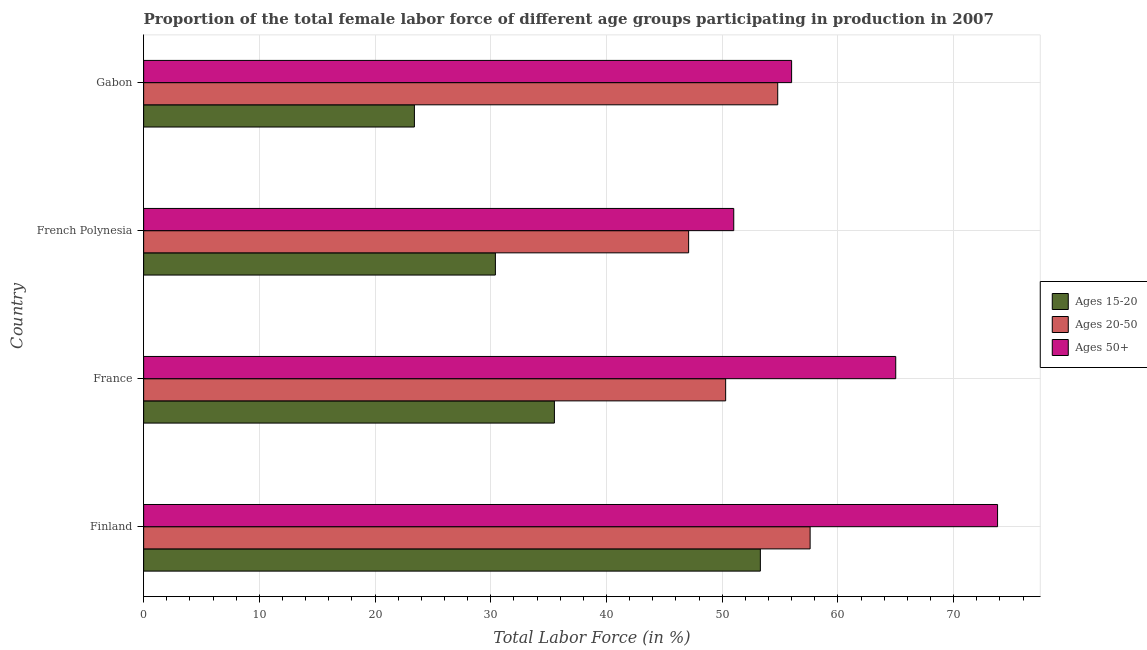How many different coloured bars are there?
Your answer should be compact. 3. Are the number of bars per tick equal to the number of legend labels?
Keep it short and to the point. Yes. How many bars are there on the 4th tick from the top?
Provide a succinct answer. 3. How many bars are there on the 4th tick from the bottom?
Offer a very short reply. 3. What is the label of the 3rd group of bars from the top?
Ensure brevity in your answer.  France. What is the percentage of female labor force within the age group 15-20 in French Polynesia?
Your answer should be very brief. 30.4. Across all countries, what is the maximum percentage of female labor force above age 50?
Your answer should be compact. 73.8. In which country was the percentage of female labor force within the age group 15-20 minimum?
Provide a succinct answer. Gabon. What is the total percentage of female labor force within the age group 15-20 in the graph?
Your answer should be very brief. 142.6. What is the difference between the percentage of female labor force within the age group 20-50 in French Polynesia and the percentage of female labor force above age 50 in France?
Offer a terse response. -17.9. What is the average percentage of female labor force within the age group 15-20 per country?
Provide a succinct answer. 35.65. What is the difference between the percentage of female labor force within the age group 20-50 and percentage of female labor force above age 50 in French Polynesia?
Your answer should be very brief. -3.9. In how many countries, is the percentage of female labor force above age 50 greater than 24 %?
Make the answer very short. 4. What is the ratio of the percentage of female labor force above age 50 in Finland to that in French Polynesia?
Give a very brief answer. 1.45. Is the percentage of female labor force within the age group 15-20 in Finland less than that in Gabon?
Provide a short and direct response. No. What is the difference between the highest and the lowest percentage of female labor force within the age group 15-20?
Provide a short and direct response. 29.9. In how many countries, is the percentage of female labor force above age 50 greater than the average percentage of female labor force above age 50 taken over all countries?
Ensure brevity in your answer.  2. Is the sum of the percentage of female labor force within the age group 15-20 in Finland and French Polynesia greater than the maximum percentage of female labor force within the age group 20-50 across all countries?
Give a very brief answer. Yes. What does the 1st bar from the top in Finland represents?
Offer a very short reply. Ages 50+. What does the 1st bar from the bottom in France represents?
Your answer should be very brief. Ages 15-20. What is the difference between two consecutive major ticks on the X-axis?
Make the answer very short. 10. Are the values on the major ticks of X-axis written in scientific E-notation?
Provide a short and direct response. No. Does the graph contain grids?
Give a very brief answer. Yes. How many legend labels are there?
Give a very brief answer. 3. What is the title of the graph?
Make the answer very short. Proportion of the total female labor force of different age groups participating in production in 2007. What is the Total Labor Force (in %) in Ages 15-20 in Finland?
Provide a short and direct response. 53.3. What is the Total Labor Force (in %) of Ages 20-50 in Finland?
Ensure brevity in your answer.  57.6. What is the Total Labor Force (in %) in Ages 50+ in Finland?
Give a very brief answer. 73.8. What is the Total Labor Force (in %) of Ages 15-20 in France?
Make the answer very short. 35.5. What is the Total Labor Force (in %) in Ages 20-50 in France?
Keep it short and to the point. 50.3. What is the Total Labor Force (in %) of Ages 15-20 in French Polynesia?
Your response must be concise. 30.4. What is the Total Labor Force (in %) in Ages 20-50 in French Polynesia?
Keep it short and to the point. 47.1. What is the Total Labor Force (in %) in Ages 15-20 in Gabon?
Offer a very short reply. 23.4. What is the Total Labor Force (in %) in Ages 20-50 in Gabon?
Your response must be concise. 54.8. Across all countries, what is the maximum Total Labor Force (in %) of Ages 15-20?
Provide a succinct answer. 53.3. Across all countries, what is the maximum Total Labor Force (in %) in Ages 20-50?
Offer a terse response. 57.6. Across all countries, what is the maximum Total Labor Force (in %) of Ages 50+?
Make the answer very short. 73.8. Across all countries, what is the minimum Total Labor Force (in %) of Ages 15-20?
Your response must be concise. 23.4. Across all countries, what is the minimum Total Labor Force (in %) of Ages 20-50?
Offer a very short reply. 47.1. Across all countries, what is the minimum Total Labor Force (in %) in Ages 50+?
Offer a very short reply. 51. What is the total Total Labor Force (in %) of Ages 15-20 in the graph?
Keep it short and to the point. 142.6. What is the total Total Labor Force (in %) of Ages 20-50 in the graph?
Give a very brief answer. 209.8. What is the total Total Labor Force (in %) of Ages 50+ in the graph?
Your answer should be very brief. 245.8. What is the difference between the Total Labor Force (in %) of Ages 15-20 in Finland and that in France?
Your response must be concise. 17.8. What is the difference between the Total Labor Force (in %) in Ages 20-50 in Finland and that in France?
Make the answer very short. 7.3. What is the difference between the Total Labor Force (in %) of Ages 50+ in Finland and that in France?
Give a very brief answer. 8.8. What is the difference between the Total Labor Force (in %) in Ages 15-20 in Finland and that in French Polynesia?
Your answer should be compact. 22.9. What is the difference between the Total Labor Force (in %) of Ages 20-50 in Finland and that in French Polynesia?
Provide a succinct answer. 10.5. What is the difference between the Total Labor Force (in %) in Ages 50+ in Finland and that in French Polynesia?
Provide a short and direct response. 22.8. What is the difference between the Total Labor Force (in %) of Ages 15-20 in Finland and that in Gabon?
Make the answer very short. 29.9. What is the difference between the Total Labor Force (in %) of Ages 50+ in Finland and that in Gabon?
Your response must be concise. 17.8. What is the difference between the Total Labor Force (in %) of Ages 20-50 in France and that in Gabon?
Offer a terse response. -4.5. What is the difference between the Total Labor Force (in %) of Ages 15-20 in French Polynesia and that in Gabon?
Your response must be concise. 7. What is the difference between the Total Labor Force (in %) of Ages 20-50 in French Polynesia and that in Gabon?
Provide a succinct answer. -7.7. What is the difference between the Total Labor Force (in %) in Ages 50+ in French Polynesia and that in Gabon?
Your answer should be compact. -5. What is the difference between the Total Labor Force (in %) in Ages 15-20 in Finland and the Total Labor Force (in %) in Ages 20-50 in France?
Make the answer very short. 3. What is the difference between the Total Labor Force (in %) of Ages 15-20 in Finland and the Total Labor Force (in %) of Ages 50+ in France?
Your answer should be compact. -11.7. What is the difference between the Total Labor Force (in %) of Ages 15-20 in Finland and the Total Labor Force (in %) of Ages 50+ in French Polynesia?
Keep it short and to the point. 2.3. What is the difference between the Total Labor Force (in %) in Ages 20-50 in Finland and the Total Labor Force (in %) in Ages 50+ in French Polynesia?
Your answer should be very brief. 6.6. What is the difference between the Total Labor Force (in %) in Ages 15-20 in Finland and the Total Labor Force (in %) in Ages 20-50 in Gabon?
Provide a succinct answer. -1.5. What is the difference between the Total Labor Force (in %) of Ages 15-20 in Finland and the Total Labor Force (in %) of Ages 50+ in Gabon?
Offer a very short reply. -2.7. What is the difference between the Total Labor Force (in %) of Ages 20-50 in Finland and the Total Labor Force (in %) of Ages 50+ in Gabon?
Offer a very short reply. 1.6. What is the difference between the Total Labor Force (in %) of Ages 15-20 in France and the Total Labor Force (in %) of Ages 20-50 in French Polynesia?
Offer a very short reply. -11.6. What is the difference between the Total Labor Force (in %) in Ages 15-20 in France and the Total Labor Force (in %) in Ages 50+ in French Polynesia?
Provide a succinct answer. -15.5. What is the difference between the Total Labor Force (in %) of Ages 15-20 in France and the Total Labor Force (in %) of Ages 20-50 in Gabon?
Offer a terse response. -19.3. What is the difference between the Total Labor Force (in %) of Ages 15-20 in France and the Total Labor Force (in %) of Ages 50+ in Gabon?
Make the answer very short. -20.5. What is the difference between the Total Labor Force (in %) of Ages 20-50 in France and the Total Labor Force (in %) of Ages 50+ in Gabon?
Give a very brief answer. -5.7. What is the difference between the Total Labor Force (in %) in Ages 15-20 in French Polynesia and the Total Labor Force (in %) in Ages 20-50 in Gabon?
Your answer should be compact. -24.4. What is the difference between the Total Labor Force (in %) in Ages 15-20 in French Polynesia and the Total Labor Force (in %) in Ages 50+ in Gabon?
Keep it short and to the point. -25.6. What is the average Total Labor Force (in %) of Ages 15-20 per country?
Ensure brevity in your answer.  35.65. What is the average Total Labor Force (in %) of Ages 20-50 per country?
Offer a terse response. 52.45. What is the average Total Labor Force (in %) of Ages 50+ per country?
Give a very brief answer. 61.45. What is the difference between the Total Labor Force (in %) in Ages 15-20 and Total Labor Force (in %) in Ages 20-50 in Finland?
Your answer should be very brief. -4.3. What is the difference between the Total Labor Force (in %) of Ages 15-20 and Total Labor Force (in %) of Ages 50+ in Finland?
Offer a very short reply. -20.5. What is the difference between the Total Labor Force (in %) of Ages 20-50 and Total Labor Force (in %) of Ages 50+ in Finland?
Ensure brevity in your answer.  -16.2. What is the difference between the Total Labor Force (in %) in Ages 15-20 and Total Labor Force (in %) in Ages 20-50 in France?
Ensure brevity in your answer.  -14.8. What is the difference between the Total Labor Force (in %) in Ages 15-20 and Total Labor Force (in %) in Ages 50+ in France?
Keep it short and to the point. -29.5. What is the difference between the Total Labor Force (in %) of Ages 20-50 and Total Labor Force (in %) of Ages 50+ in France?
Give a very brief answer. -14.7. What is the difference between the Total Labor Force (in %) of Ages 15-20 and Total Labor Force (in %) of Ages 20-50 in French Polynesia?
Your answer should be very brief. -16.7. What is the difference between the Total Labor Force (in %) of Ages 15-20 and Total Labor Force (in %) of Ages 50+ in French Polynesia?
Offer a very short reply. -20.6. What is the difference between the Total Labor Force (in %) of Ages 15-20 and Total Labor Force (in %) of Ages 20-50 in Gabon?
Provide a succinct answer. -31.4. What is the difference between the Total Labor Force (in %) in Ages 15-20 and Total Labor Force (in %) in Ages 50+ in Gabon?
Provide a succinct answer. -32.6. What is the ratio of the Total Labor Force (in %) in Ages 15-20 in Finland to that in France?
Your answer should be very brief. 1.5. What is the ratio of the Total Labor Force (in %) in Ages 20-50 in Finland to that in France?
Give a very brief answer. 1.15. What is the ratio of the Total Labor Force (in %) of Ages 50+ in Finland to that in France?
Provide a short and direct response. 1.14. What is the ratio of the Total Labor Force (in %) in Ages 15-20 in Finland to that in French Polynesia?
Offer a very short reply. 1.75. What is the ratio of the Total Labor Force (in %) in Ages 20-50 in Finland to that in French Polynesia?
Your answer should be compact. 1.22. What is the ratio of the Total Labor Force (in %) of Ages 50+ in Finland to that in French Polynesia?
Your response must be concise. 1.45. What is the ratio of the Total Labor Force (in %) in Ages 15-20 in Finland to that in Gabon?
Make the answer very short. 2.28. What is the ratio of the Total Labor Force (in %) of Ages 20-50 in Finland to that in Gabon?
Provide a succinct answer. 1.05. What is the ratio of the Total Labor Force (in %) of Ages 50+ in Finland to that in Gabon?
Your response must be concise. 1.32. What is the ratio of the Total Labor Force (in %) of Ages 15-20 in France to that in French Polynesia?
Give a very brief answer. 1.17. What is the ratio of the Total Labor Force (in %) in Ages 20-50 in France to that in French Polynesia?
Ensure brevity in your answer.  1.07. What is the ratio of the Total Labor Force (in %) of Ages 50+ in France to that in French Polynesia?
Keep it short and to the point. 1.27. What is the ratio of the Total Labor Force (in %) of Ages 15-20 in France to that in Gabon?
Ensure brevity in your answer.  1.52. What is the ratio of the Total Labor Force (in %) in Ages 20-50 in France to that in Gabon?
Offer a terse response. 0.92. What is the ratio of the Total Labor Force (in %) in Ages 50+ in France to that in Gabon?
Give a very brief answer. 1.16. What is the ratio of the Total Labor Force (in %) in Ages 15-20 in French Polynesia to that in Gabon?
Make the answer very short. 1.3. What is the ratio of the Total Labor Force (in %) of Ages 20-50 in French Polynesia to that in Gabon?
Your answer should be compact. 0.86. What is the ratio of the Total Labor Force (in %) in Ages 50+ in French Polynesia to that in Gabon?
Ensure brevity in your answer.  0.91. What is the difference between the highest and the second highest Total Labor Force (in %) of Ages 15-20?
Offer a very short reply. 17.8. What is the difference between the highest and the second highest Total Labor Force (in %) in Ages 20-50?
Give a very brief answer. 2.8. What is the difference between the highest and the lowest Total Labor Force (in %) of Ages 15-20?
Offer a terse response. 29.9. What is the difference between the highest and the lowest Total Labor Force (in %) in Ages 20-50?
Ensure brevity in your answer.  10.5. What is the difference between the highest and the lowest Total Labor Force (in %) in Ages 50+?
Your response must be concise. 22.8. 